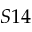<formula> <loc_0><loc_0><loc_500><loc_500>S 1 4</formula> 